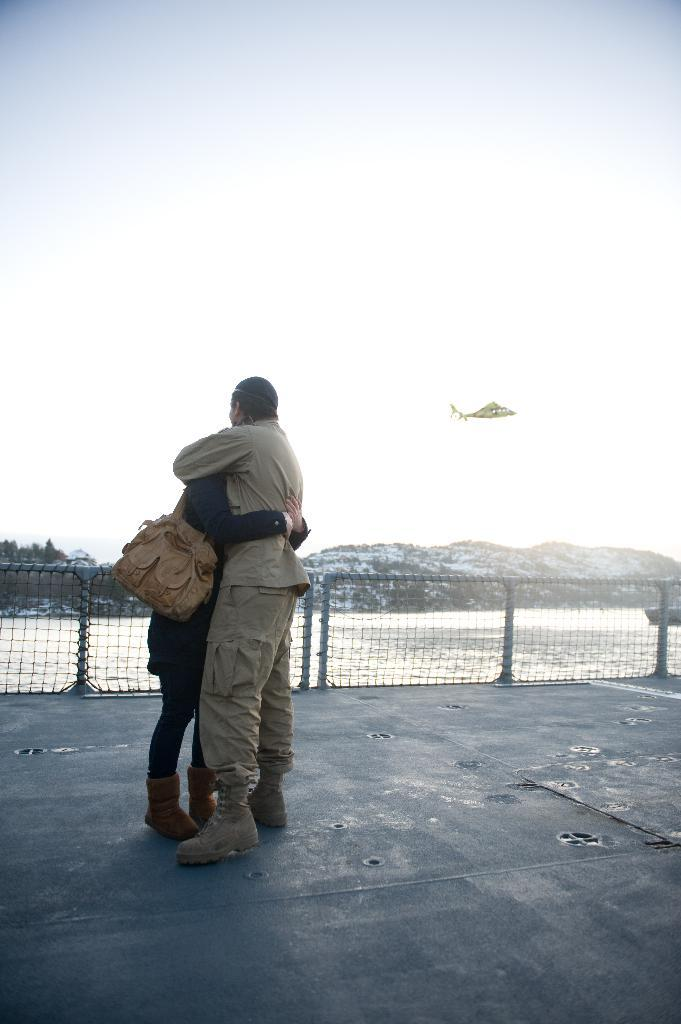How many people are in the image? There are two people standing in the image. What is the surface they are standing on? The people are standing on the floor. What can be seen in the image besides the people? There is a fencing net, water, trees, mountains, and a helicopter flying in the sky in the background of the image. What type of patch is sewn onto the stomach of the person on the left? There is no patch visible on the stomach of the person on the left, as the image does not show any clothing details. 